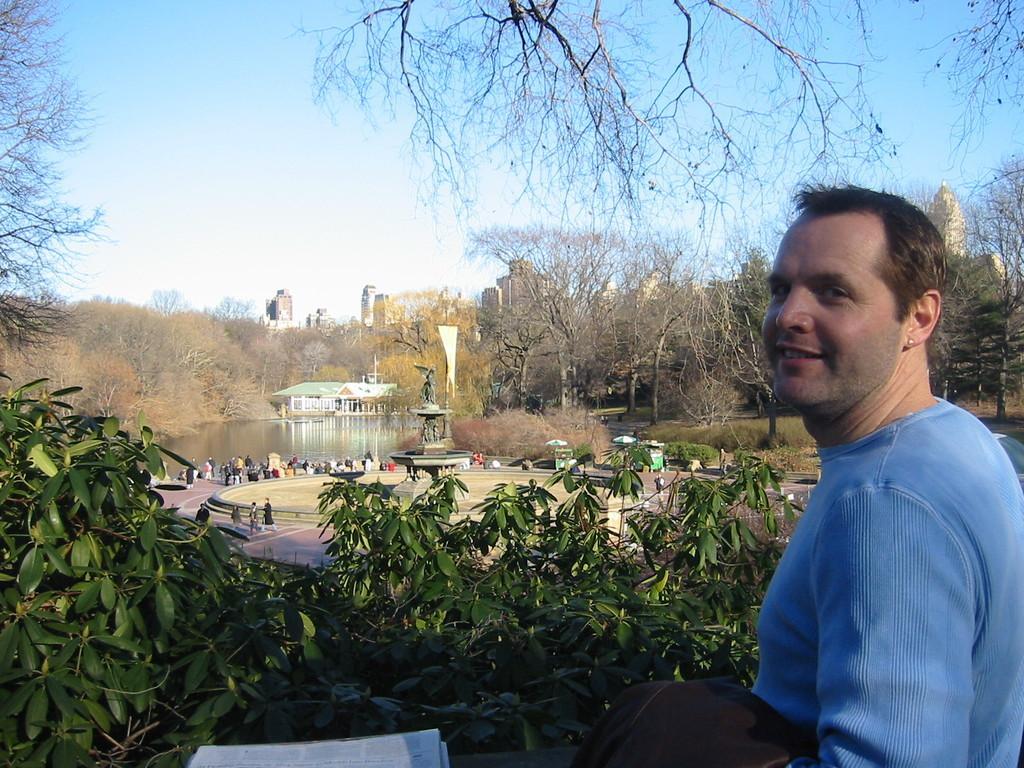Can you describe this image briefly? In this image in the front there is a man standing and smiling and in the center there are plants. In the background there are persons walking and there are trees, there is water and there are buildings. 